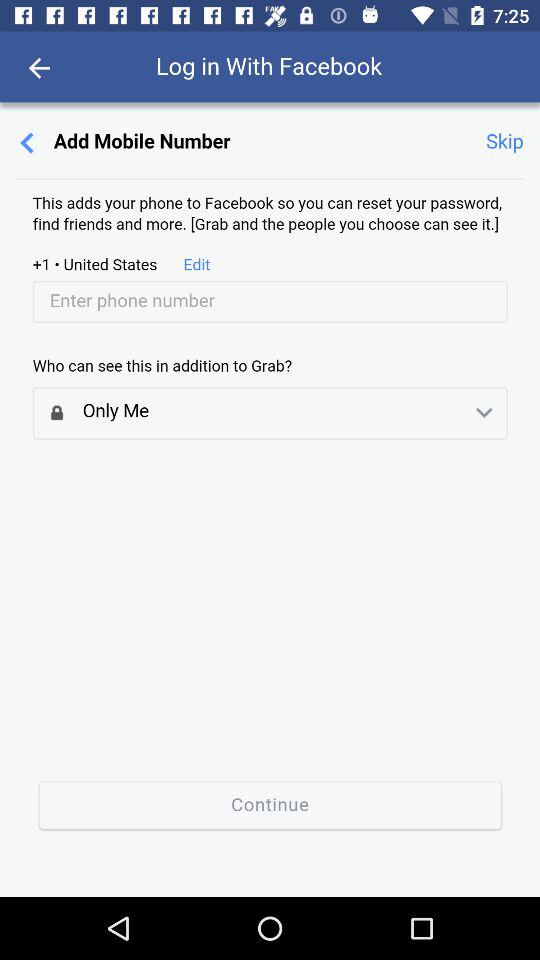How many people can see my mobile number in addition to Grab?
Answer the question using a single word or phrase. Only Me 